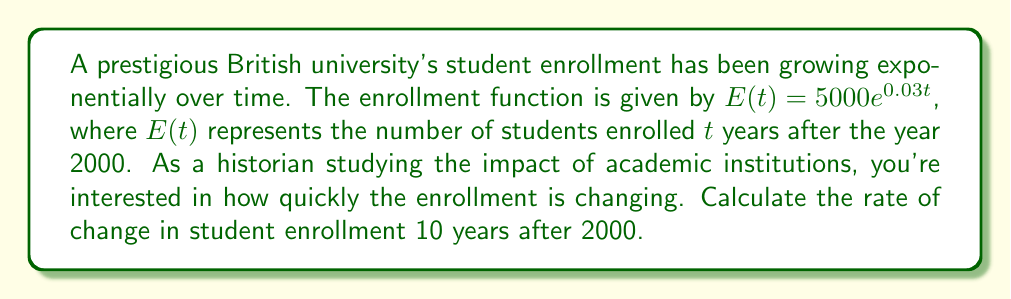Could you help me with this problem? To find the rate of change in student enrollment, we need to differentiate the enrollment function $E(t)$ with respect to time $t$ and then evaluate it at $t=10$.

Step 1: Differentiate $E(t)$ with respect to $t$
$$\frac{d}{dt}E(t) = \frac{d}{dt}(5000e^{0.03t})$$
Using the chain rule:
$$\frac{d}{dt}E(t) = 5000 \cdot 0.03 \cdot e^{0.03t}$$
$$\frac{d}{dt}E(t) = 150e^{0.03t}$$

Step 2: Evaluate $\frac{d}{dt}E(t)$ at $t=10$
$$\left.\frac{d}{dt}E(t)\right|_{t=10} = 150e^{0.03(10)}$$
$$\left.\frac{d}{dt}E(t)\right|_{t=10} = 150e^{0.3}$$
$$\left.\frac{d}{dt}E(t)\right|_{t=10} = 150 \cdot 1.34986$$
$$\left.\frac{d}{dt}E(t)\right|_{t=10} \approx 202.479$$

The rate of change in student enrollment 10 years after 2000 is approximately 202.479 students per year.
Answer: 202.479 students/year 